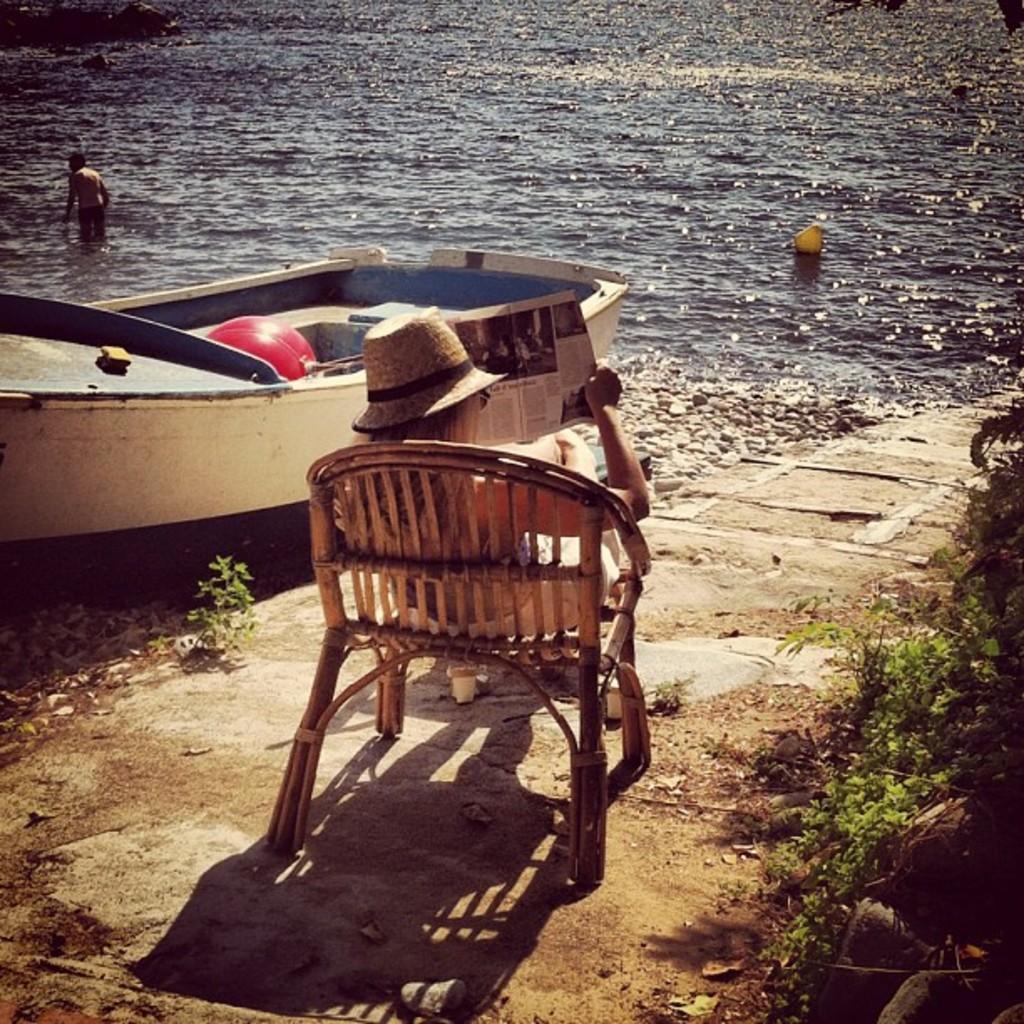Describe this image in one or two sentences. In this picture we can see a man in a river. this is a boat. We can one woman sitting on a chair and reading newspaper. We can see pebbles here. These are plants. 